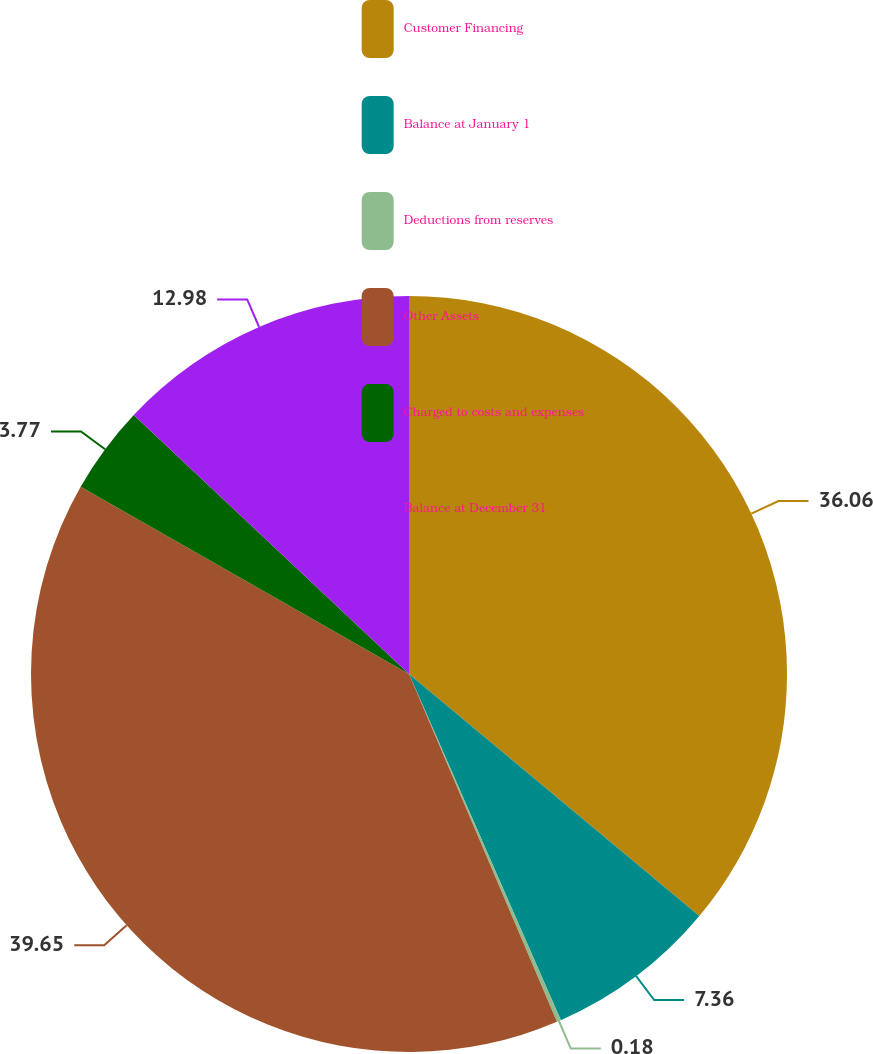<chart> <loc_0><loc_0><loc_500><loc_500><pie_chart><fcel>Customer Financing<fcel>Balance at January 1<fcel>Deductions from reserves<fcel>Other Assets<fcel>Charged to costs and expenses<fcel>Balance at December 31<nl><fcel>36.06%<fcel>7.36%<fcel>0.18%<fcel>39.65%<fcel>3.77%<fcel>12.98%<nl></chart> 